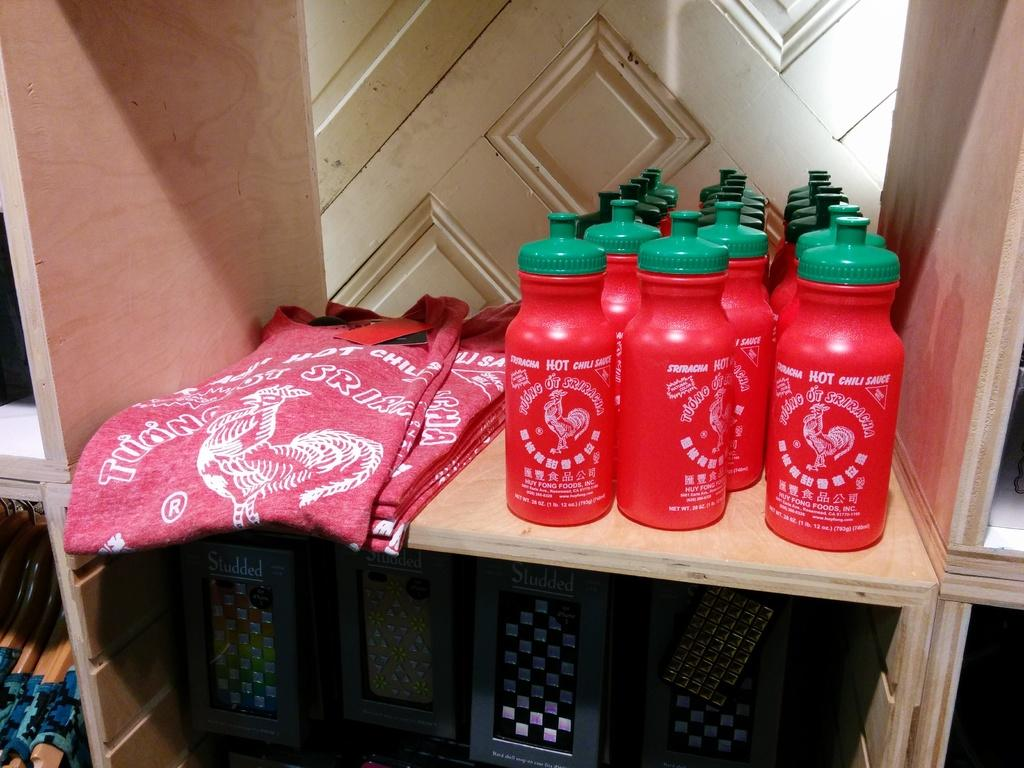What type of clothing items can be seen in the image? There are t-shirts in the image. What condiment is present in the image? There are hot chili sauce bottles in the image. What type of boxes are visible in the image? There are studded boxes in the image. How are the items arranged in the image? The items are placed on wooden racks. What type of storage space is visible in the image? There is a closet in the image. How does the head of the person in the image affect the range of the t-shirts? There is no person present in the image, so it is not possible to determine how their head might affect the range of the t-shirts. 